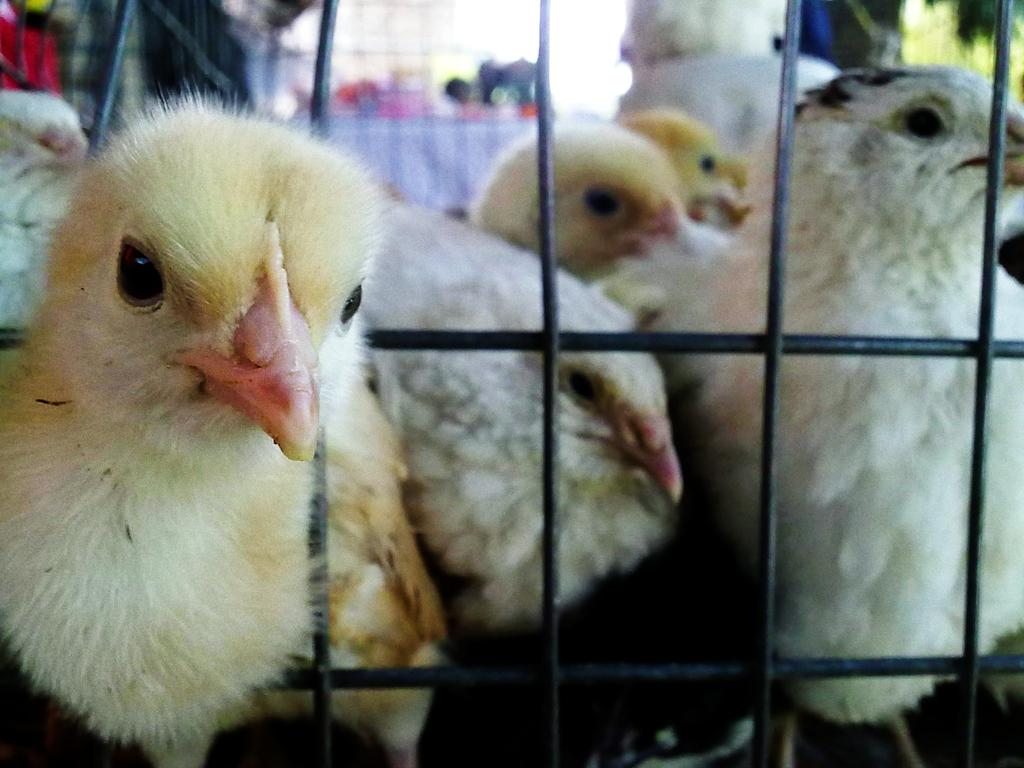What type of animals are in the image? There are chicks in the image. Where are the chicks located? The chicks are in a cage. What type of jewel can be seen hanging from the cage in the image? There is no jewel hanging from the cage in the image; it only features chicks in a cage. 